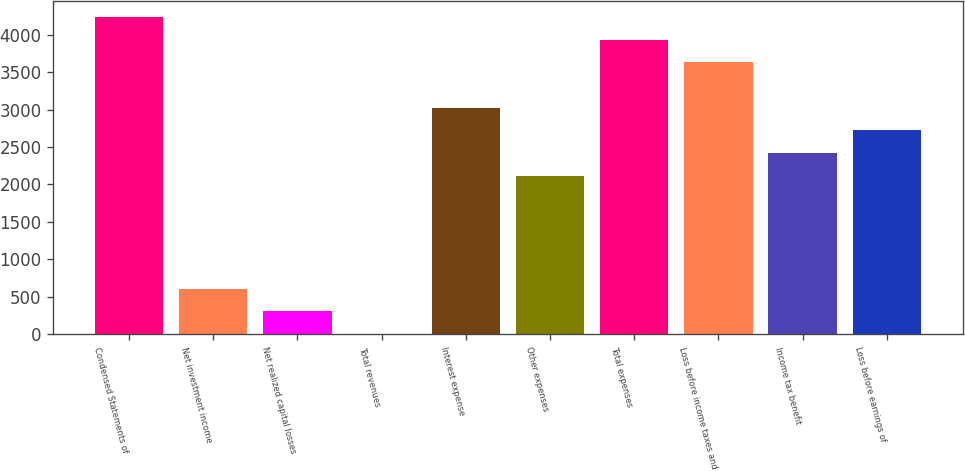<chart> <loc_0><loc_0><loc_500><loc_500><bar_chart><fcel>Condensed Statements of<fcel>Net investment income<fcel>Net realized capital losses<fcel>Total revenues<fcel>Interest expense<fcel>Other expenses<fcel>Total expenses<fcel>Loss before income taxes and<fcel>Income tax benefit<fcel>Loss before earnings of<nl><fcel>4233.8<fcel>607.4<fcel>305.2<fcel>3<fcel>3025<fcel>2118.4<fcel>3931.6<fcel>3629.4<fcel>2420.6<fcel>2722.8<nl></chart> 